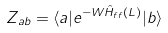<formula> <loc_0><loc_0><loc_500><loc_500>Z _ { a b } = \langle a | e ^ { - W \hat { H } _ { f f } ( L ) } | b \rangle</formula> 